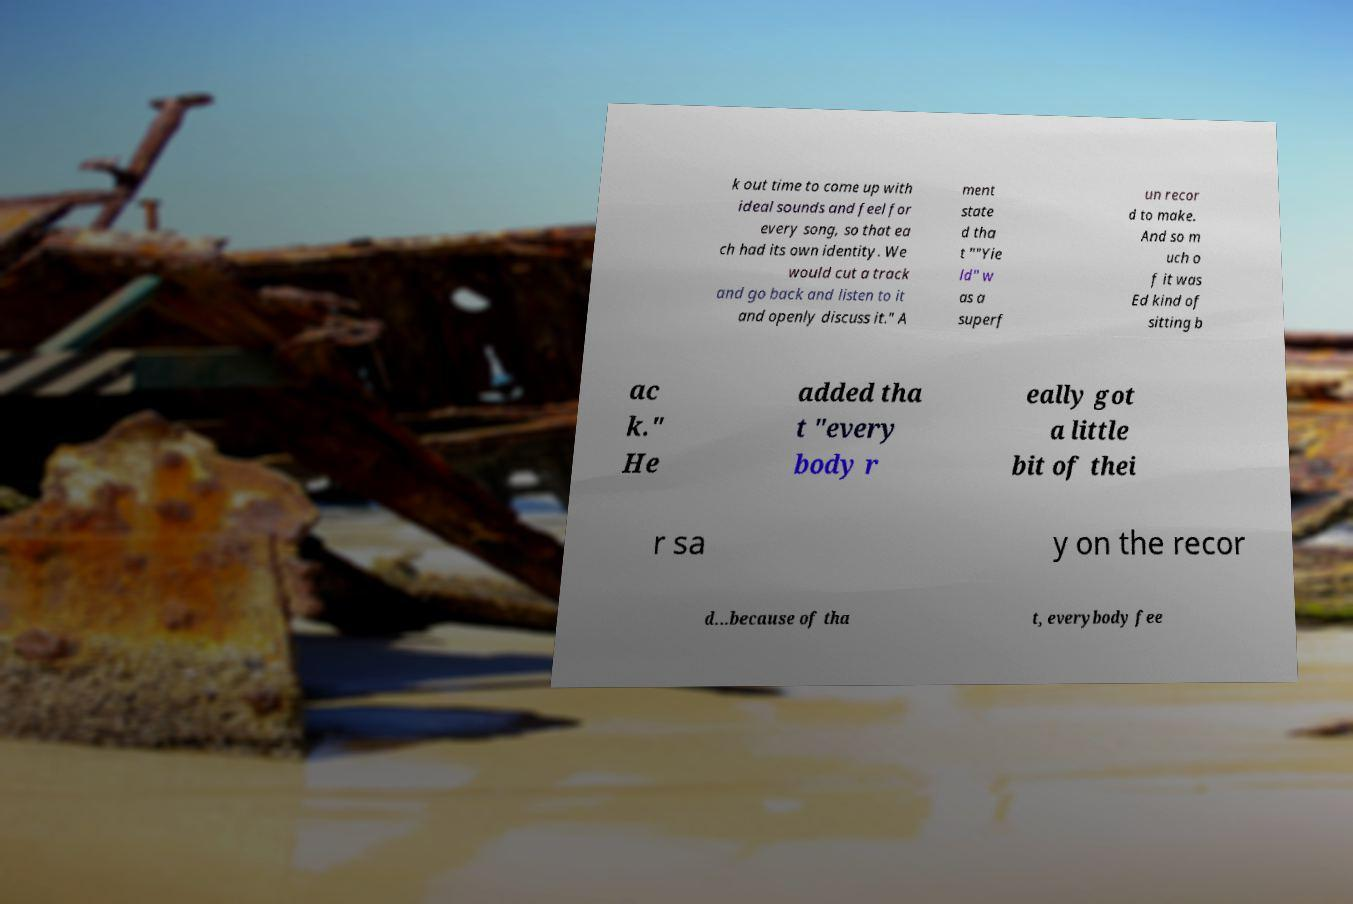There's text embedded in this image that I need extracted. Can you transcribe it verbatim? k out time to come up with ideal sounds and feel for every song, so that ea ch had its own identity. We would cut a track and go back and listen to it and openly discuss it." A ment state d tha t ""Yie ld" w as a superf un recor d to make. And so m uch o f it was Ed kind of sitting b ac k." He added tha t "every body r eally got a little bit of thei r sa y on the recor d...because of tha t, everybody fee 